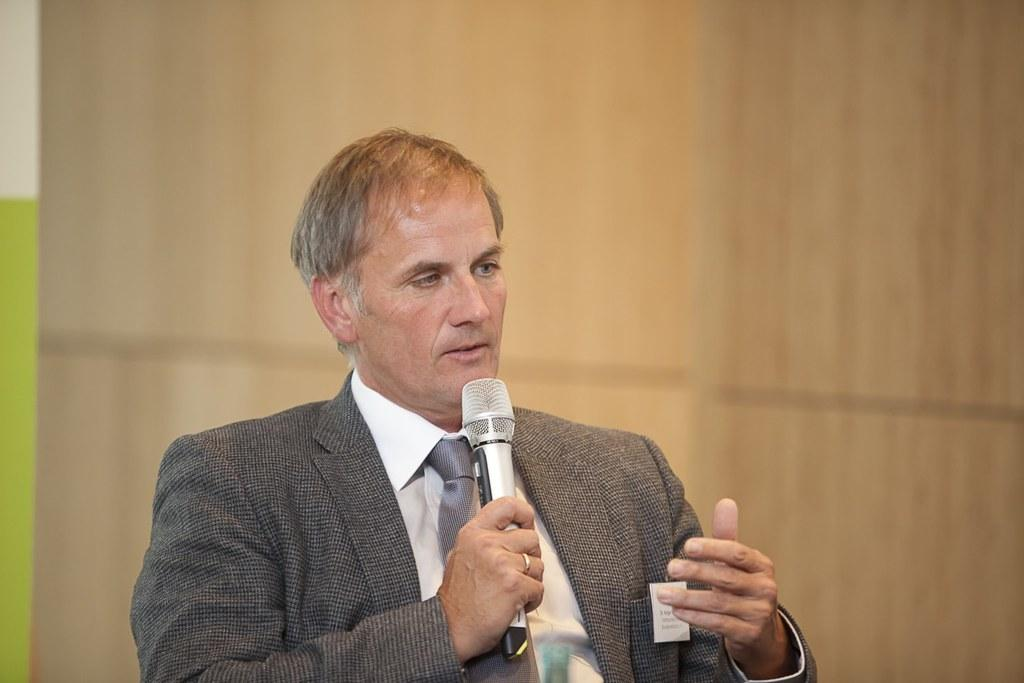What is the main subject of the image? The main subject of the image is a man. Can you describe the man's clothing in the image? The man is wearing a grey blazer and a white shirt in the image. What is the man holding in his hand? The man is holding a microphone in his hand. What might the man be doing with the microphone? The man might be talking on the microphone. What can be seen behind the man in the image? There is a wall visible behind the man in the image. What type of dock can be seen in the image? There is no dock present in the image; it features a man holding a microphone and wearing a grey blazer and a white shirt. 